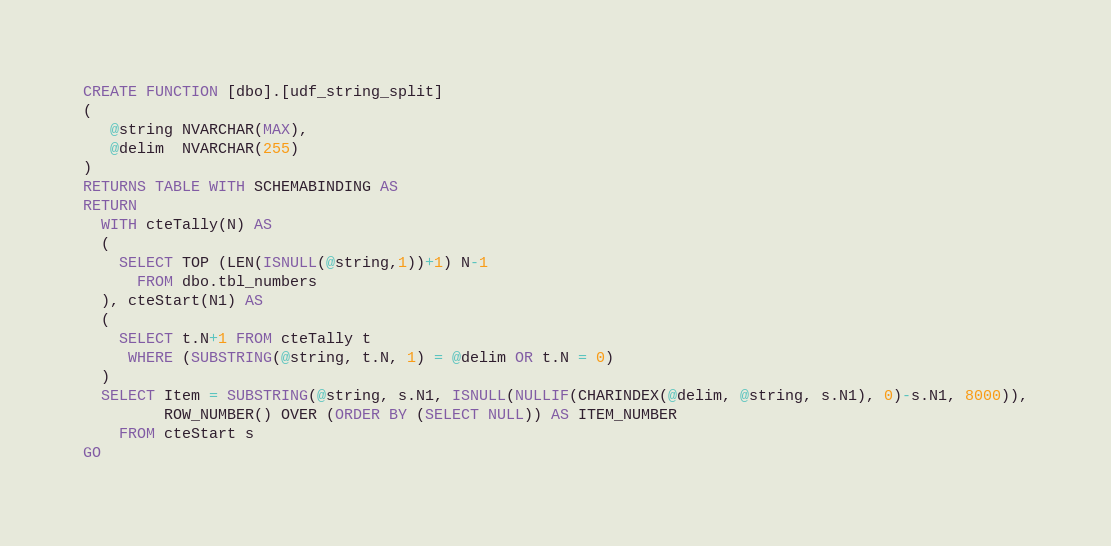<code> <loc_0><loc_0><loc_500><loc_500><_SQL_>CREATE FUNCTION [dbo].[udf_string_split]
(
   @string NVARCHAR(MAX),
   @delim  NVARCHAR(255)
)
RETURNS TABLE WITH SCHEMABINDING AS
RETURN
  WITH cteTally(N) AS 
  (
	SELECT TOP (LEN(ISNULL(@string,1))+1) N-1 
	  FROM dbo.tbl_numbers
  ), cteStart(N1) AS 
  (
	SELECT t.N+1 FROM cteTally t
     WHERE (SUBSTRING(@string, t.N, 1) = @delim OR t.N = 0)
  )
  SELECT Item = SUBSTRING(@string, s.N1, ISNULL(NULLIF(CHARINDEX(@delim, @string, s.N1), 0)-s.N1, 8000)),
		 ROW_NUMBER() OVER (ORDER BY (SELECT NULL)) AS ITEM_NUMBER
    FROM cteStart s
GO
</code> 